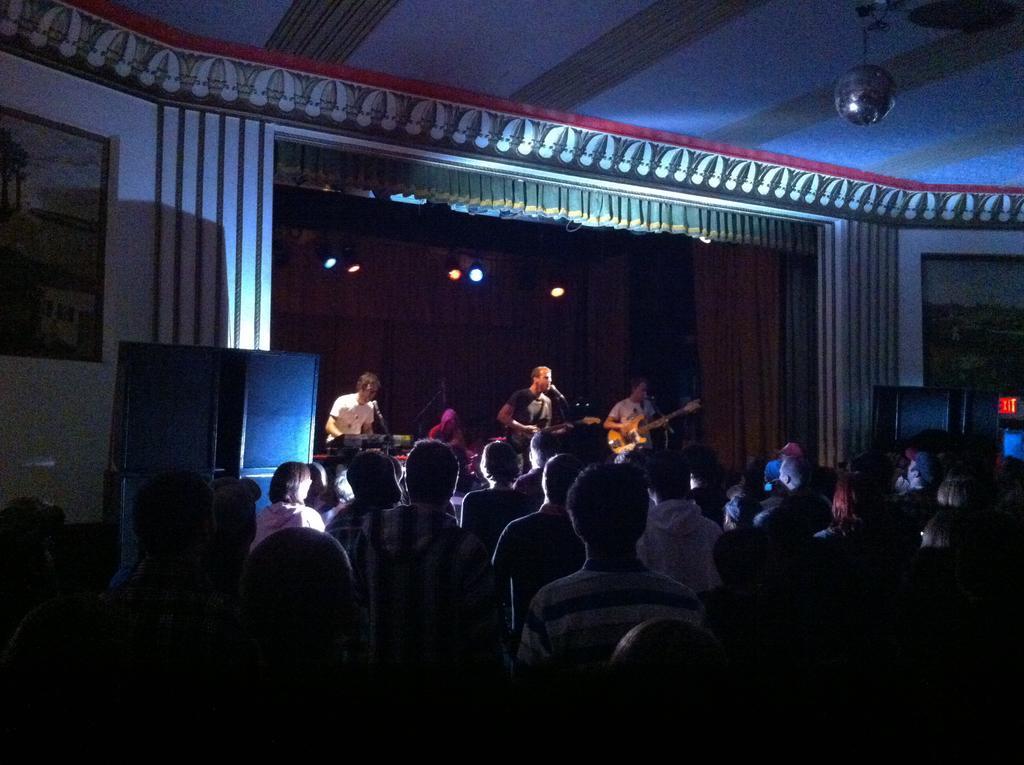How would you summarize this image in a sentence or two? In this image we can see many people. In the back there is a stage with lights. On the stage few people are playing musical instruments. There is a mic with stand. On both sides there are frames with paintings. Also there are some decorations on the stage. 